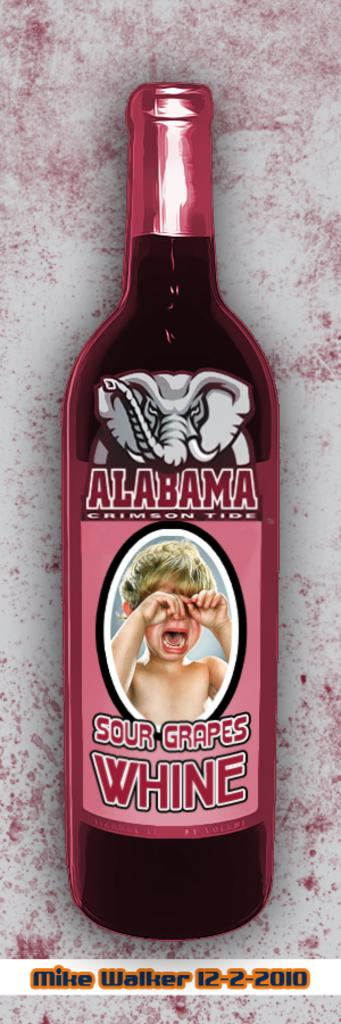<image>
Provide a brief description of the given image. A bottle of Alabama Sour Grapes Wine with a crying baby on the label. 